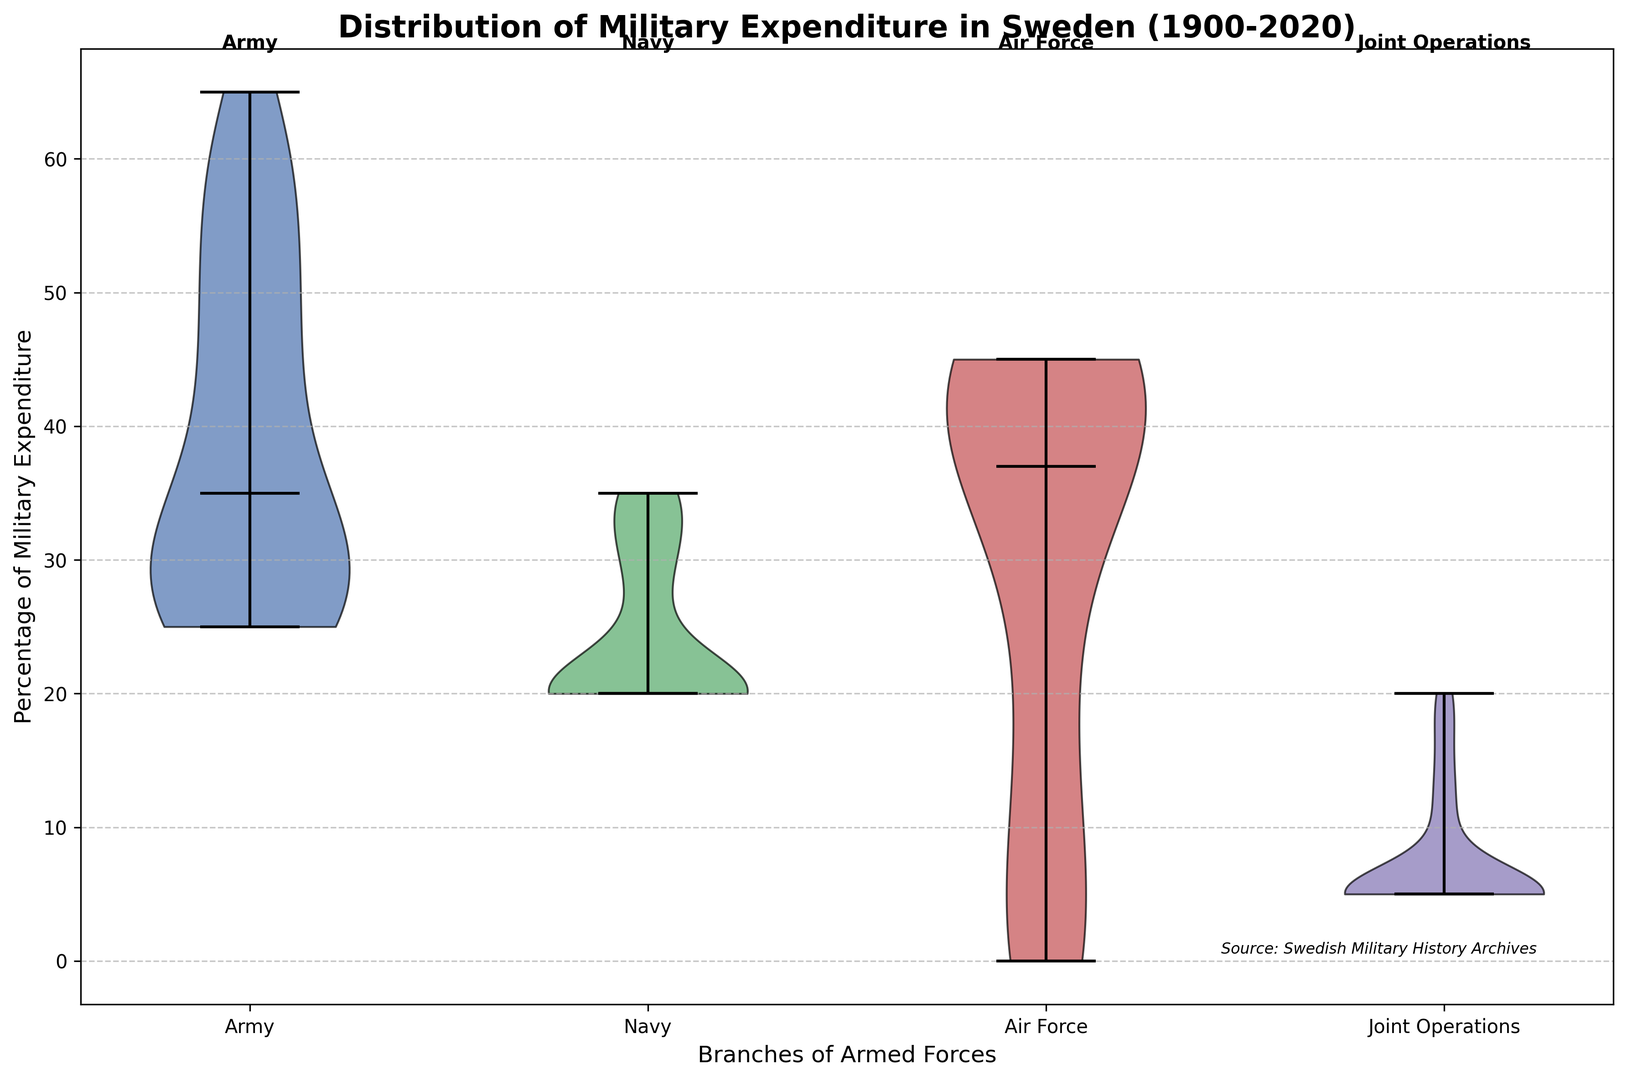What is the median percentage of military expenditure for the Army? To find the median percentage, locate the middle value of the distribution for the Army. In a violin plot, the median is typically indicated by a central line within the distribution area.
Answer: 30 Which branch has the highest median military expenditure percentage? To determine the branch with the highest median, compare the central lines within each distribution area (Army, Navy, Air Force, Joint Operations). The area with the highest central line represents the highest median percentage.
Answer: Air Force By how much did the median expenditure percentage for Air Force exceed that for Navy? Compare the central line of the Air Force with that of the Navy on the violin plot. Subtract the median of the Navy from the median of the Air Force to find the difference.
Answer: 25 Which branch shows the most variability in its military expenditure distribution? The variability is indicated by the width of the violin plot. The branch with the widest plot represents the highest variability in expenditure distribution.
Answer: Air Force Is the median military expenditure for Joint Operations higher in later years (post-2000)? Compare the central line of the Joint Operations distribution before and after the year 2000. If the central line is higher in the post-2000 period, it indicates that the median has increased.
Answer: Yes Which branches have overlapping distributions of military expenditure percentages? Look at the overlapping regions of the violin plots. If two or more distributions intersect, they have overlapping expenditure percentages.
Answer: Army and Navy What is the color associated with the Air Force expenditure distribution? Identify the color used to fill the Air Force distribution area in the violin plot.
Answer: Red How did the median military expenditure percentage for the Army change over the time period from 1900 to 2020? Observe the central line of the Army’s distribution in the violin plot. The changes in the position of the central line over time reflect the trends in the median expenditure.
Answer: Decreased Is there a branch that consistently maintained a stable expenditure percentage over the years? A stable distribution will have a less variable and consistent central line over the years. Compare the consistency of the central lines for each branch.
Answer: Joint Operations What is the approximate range of the military expenditure percentage for the Navy? The range can be determined by finding the difference between the top and bottom points of the Navy’s distribution area in the violin plot.
Answer: 20-35 